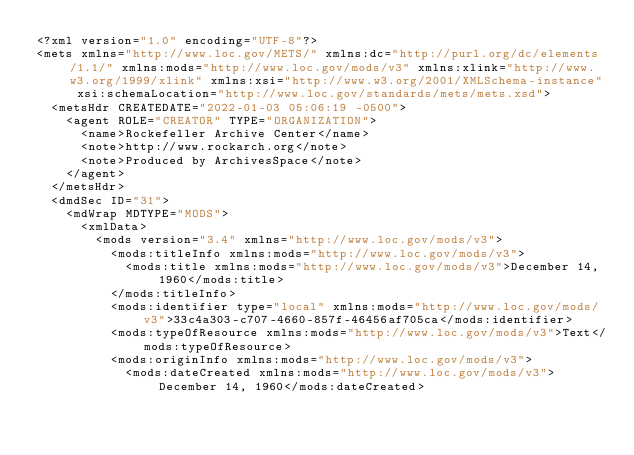Convert code to text. <code><loc_0><loc_0><loc_500><loc_500><_XML_><?xml version="1.0" encoding="UTF-8"?>
<mets xmlns="http://www.loc.gov/METS/" xmlns:dc="http://purl.org/dc/elements/1.1/" xmlns:mods="http://www.loc.gov/mods/v3" xmlns:xlink="http://www.w3.org/1999/xlink" xmlns:xsi="http://www.w3.org/2001/XMLSchema-instance" xsi:schemaLocation="http://www.loc.gov/standards/mets/mets.xsd">
  <metsHdr CREATEDATE="2022-01-03 05:06:19 -0500">
    <agent ROLE="CREATOR" TYPE="ORGANIZATION">
      <name>Rockefeller Archive Center</name>
      <note>http://www.rockarch.org</note>
      <note>Produced by ArchivesSpace</note>
    </agent>
  </metsHdr>
  <dmdSec ID="31">
    <mdWrap MDTYPE="MODS">
      <xmlData>
        <mods version="3.4" xmlns="http://www.loc.gov/mods/v3">
          <mods:titleInfo xmlns:mods="http://www.loc.gov/mods/v3">
            <mods:title xmlns:mods="http://www.loc.gov/mods/v3">December 14, 1960</mods:title>
          </mods:titleInfo>
          <mods:identifier type="local" xmlns:mods="http://www.loc.gov/mods/v3">33c4a303-c707-4660-857f-46456af705ca</mods:identifier>
          <mods:typeOfResource xmlns:mods="http://www.loc.gov/mods/v3">Text</mods:typeOfResource>
          <mods:originInfo xmlns:mods="http://www.loc.gov/mods/v3">
            <mods:dateCreated xmlns:mods="http://www.loc.gov/mods/v3">December 14, 1960</mods:dateCreated></code> 